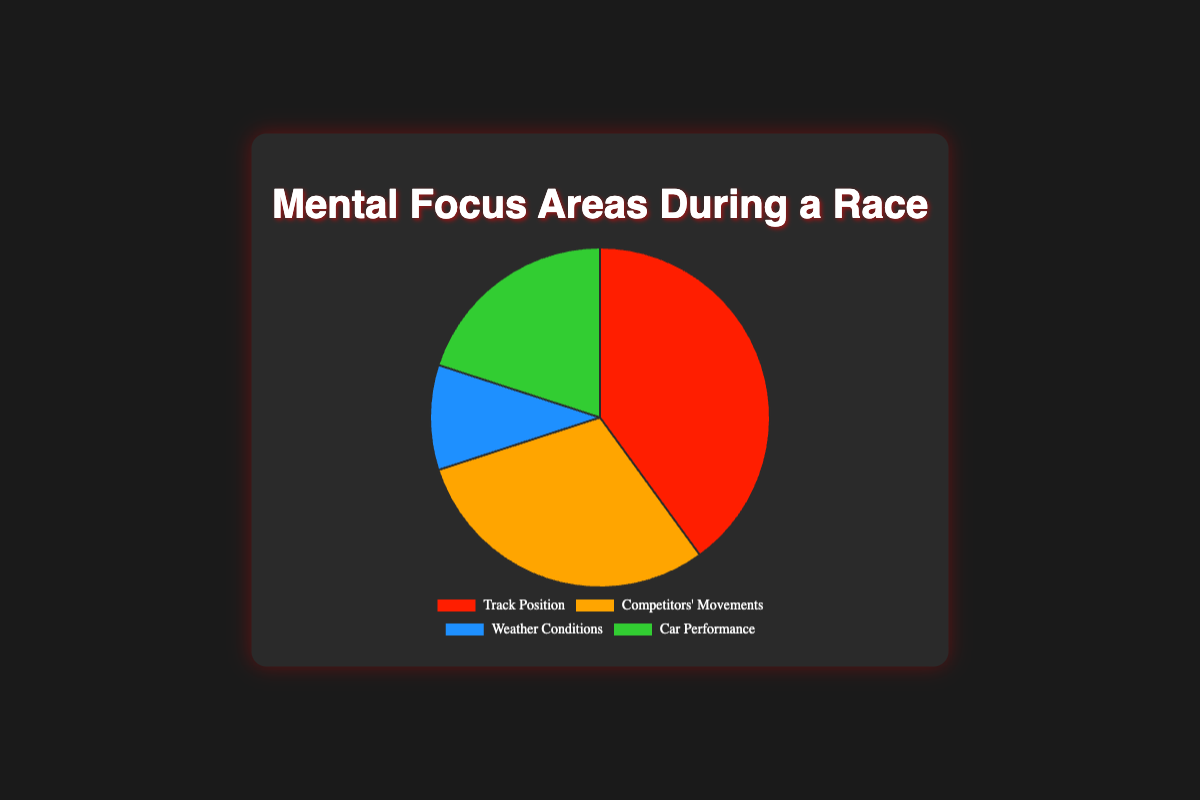What's the largest proportion of mental focus during a race? The largest proportion shown in the pie chart is for Track Position. It occupies 40%.
Answer: 40% What is the combined proportion of mental focus on Car Performance and Weather Conditions? The proportions for Car Performance and Weather Conditions are 20% and 10%, respectively. Adding these together gives 20% + 10% = 30%.
Answer: 30% How much higher is the proportion for Track Position compared to Competitors' Movements? The proportion for Track Position is 40%, and for Competitors' Movements, it's 30%. The difference is 40% - 30% = 10%.
Answer: 10% Which category has the smallest proportion of mental focus? The pie chart indicates that Weather Conditions have the smallest proportion of mental focus at 10%.
Answer: Weather Conditions What's the difference between the highest and lowest focus areas? The highest proportion is Track Position at 40%, and the lowest is Weather Conditions at 10%. The difference is 40% - 10% = 30%.
Answer: 30% Which color represents the Competitors' Movements category? In the pie chart, the Competitors' Movements category is represented by the orange color.
Answer: Orange Is the proportion of focus on Car Performance greater than that of Weather Conditions? Yes, the proportion of focus on Car Performance is 20%, which is greater than the 10% focus on Weather Conditions.
Answer: Yes How much more focus is placed on Track Position compared to Car Performance? Track Position has a focus proportion of 40%, while Car Performance has 20%. The difference is 40% - 20% = 20%.
Answer: 20% What is the average proportion of all mental focus areas combined? The four proportions are 40%, 30%, 10%, and 20%. Adding them gives 100%. The average is 100% ÷ 4 = 25%.
Answer: 25% What percentage of the focus is on areas other than Track Position? The focus on Track Position is 40%. To find the percentage of focus on the remaining categories, subtract 40% from the total 100%, which gives 100% - 40% = 60%.
Answer: 60% 